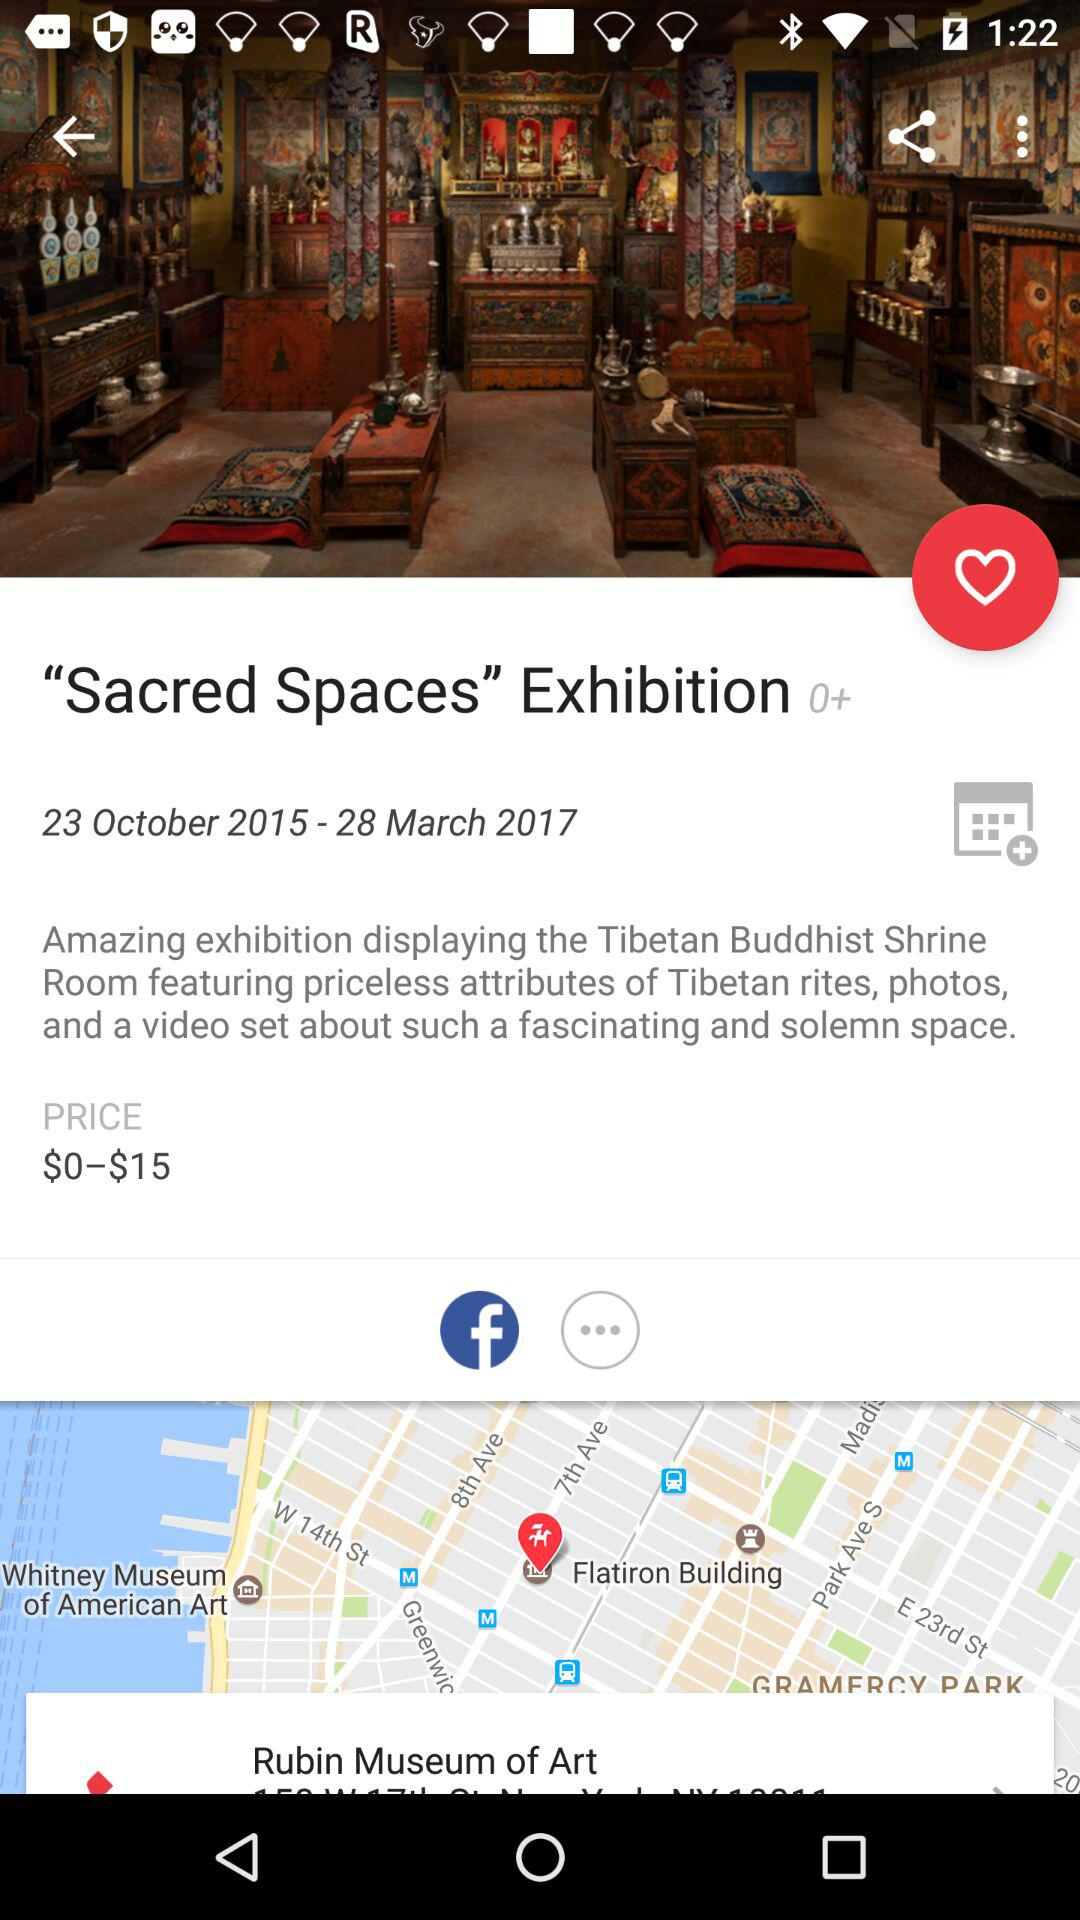What is the price of the exhibition? The price of the exhibition is $0–$15. 